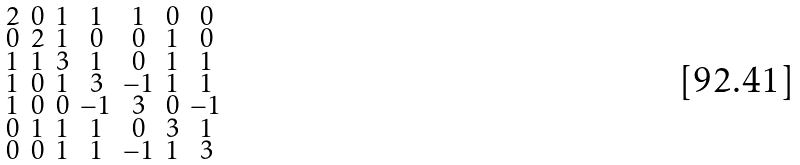Convert formula to latex. <formula><loc_0><loc_0><loc_500><loc_500>\begin{smallmatrix} 2 & 0 & 1 & 1 & 1 & 0 & 0 \\ 0 & 2 & 1 & 0 & 0 & 1 & 0 \\ 1 & 1 & 3 & 1 & 0 & 1 & 1 \\ 1 & 0 & 1 & 3 & - 1 & 1 & 1 \\ 1 & 0 & 0 & - 1 & 3 & 0 & - 1 \\ 0 & 1 & 1 & 1 & 0 & 3 & 1 \\ 0 & 0 & 1 & 1 & - 1 & 1 & 3 \end{smallmatrix}</formula> 